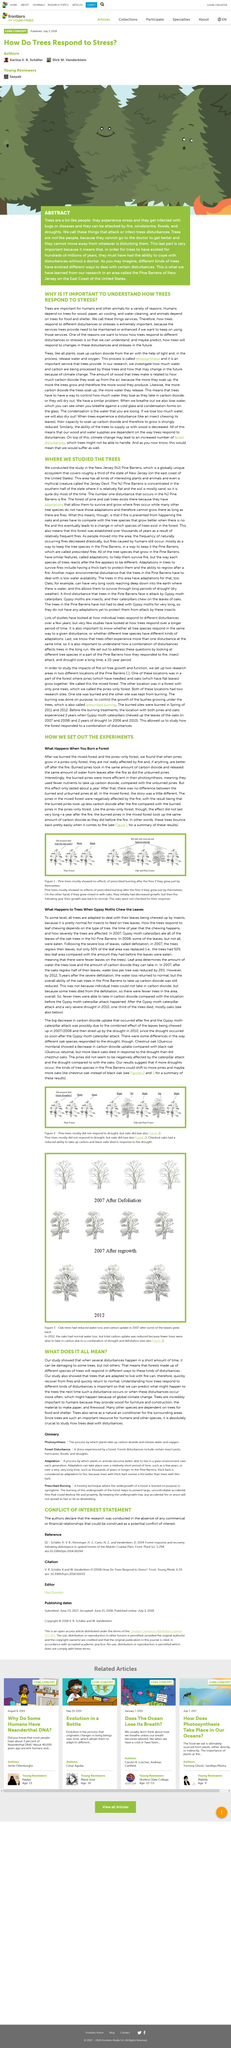Identify some key points in this picture. The trees in the image are green. Trees provide a variety of benefits to humans, including wood, paper, air cooling, and water cleaning. The goal of understanding how trees respond to various disturbances and stresses is to predict how they will respond to future changes, in order to better understand and prepare for potential impacts on forests and the environment. I am currently a student at a community college located in the city of New York, studying computer science. I have always had a passion for technology and enjoy learning about new advancements in the field. I am particularly interested in artificial intelligence and hope to one day contribute to the development of cutting-edge technologies. In my free time, I enjoy playing video games and reading about new technological advancements. I am excited to continue my studies at a four-year university and pursue a career in computer science. Animals depend on trees for their survival as they provide crucial resources such as food and shelter. 